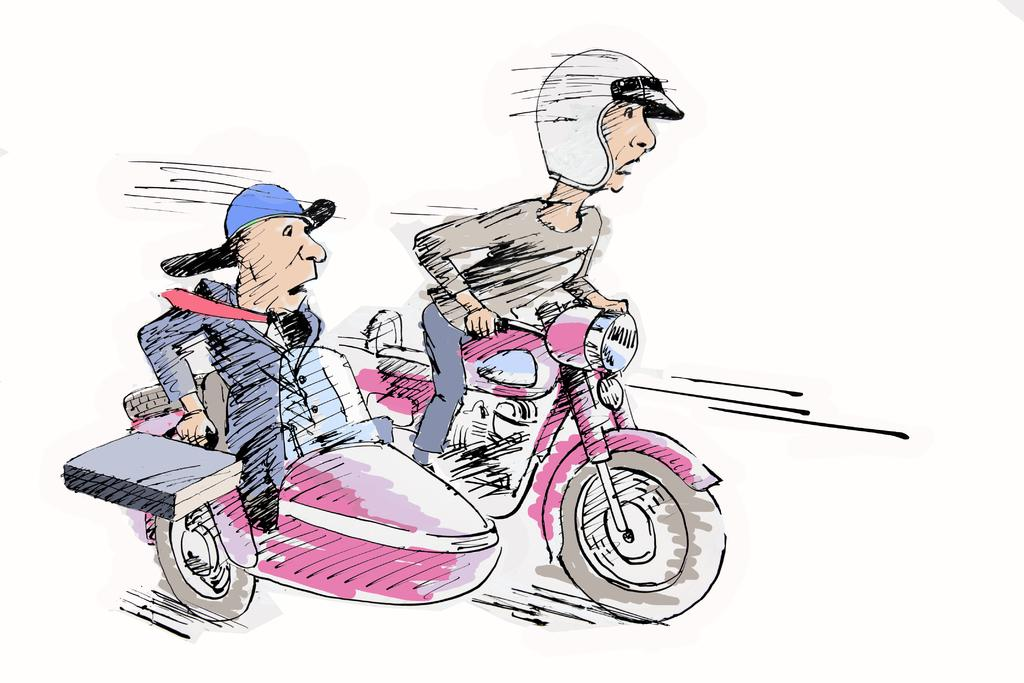What type of drawing is depicted in the image? The image is a sketch. What can be seen in the sketch? There are people in the image. What are the people doing in the sketch? The people are sitting on a motorbike. What safety precaution are the people taking in the sketch? The people are wearing helmets. What type of bird is sitting on the comb in the image? There is no bird or comb present in the image; it features a sketch of people sitting on a motorbike. 